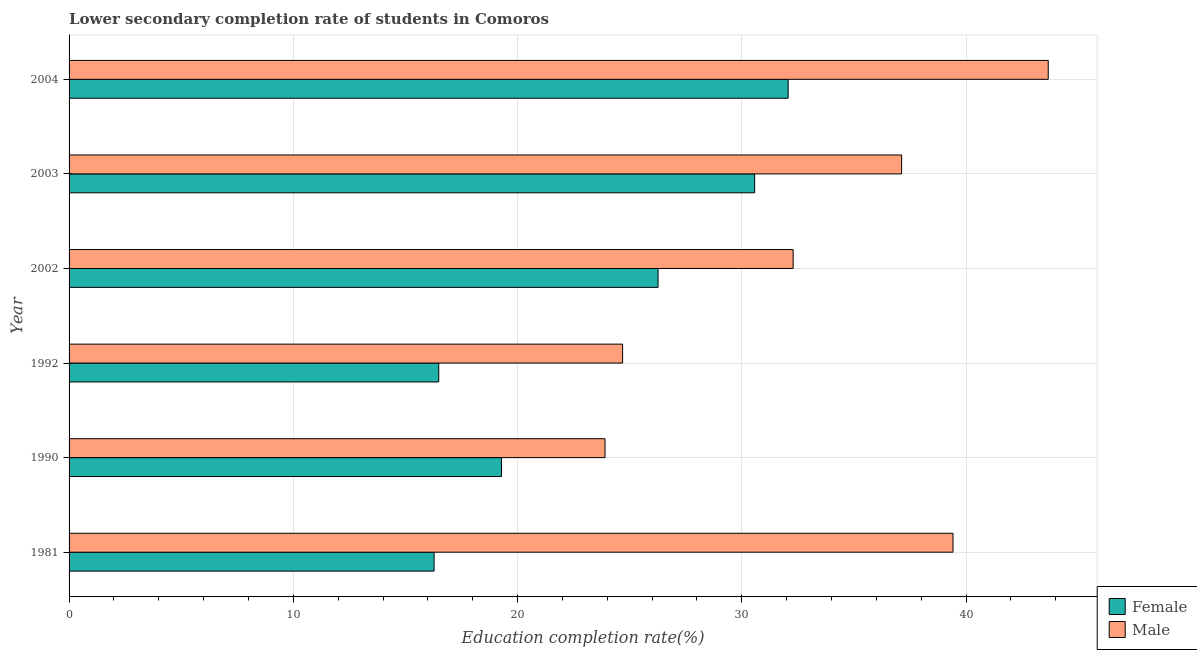How many different coloured bars are there?
Your answer should be very brief. 2. Are the number of bars per tick equal to the number of legend labels?
Provide a short and direct response. Yes. How many bars are there on the 6th tick from the top?
Offer a very short reply. 2. What is the education completion rate of female students in 1992?
Offer a very short reply. 16.49. Across all years, what is the maximum education completion rate of female students?
Offer a very short reply. 32.07. Across all years, what is the minimum education completion rate of male students?
Provide a succinct answer. 23.9. What is the total education completion rate of female students in the graph?
Provide a succinct answer. 140.95. What is the difference between the education completion rate of female students in 1990 and that in 2003?
Give a very brief answer. -11.29. What is the difference between the education completion rate of female students in 2004 and the education completion rate of male students in 1992?
Give a very brief answer. 7.38. What is the average education completion rate of male students per year?
Make the answer very short. 33.51. In the year 2002, what is the difference between the education completion rate of female students and education completion rate of male students?
Your answer should be very brief. -6.02. In how many years, is the education completion rate of male students greater than 32 %?
Keep it short and to the point. 4. What is the ratio of the education completion rate of female students in 2003 to that in 2004?
Make the answer very short. 0.95. Is the education completion rate of male students in 1981 less than that in 1992?
Your answer should be very brief. No. What is the difference between the highest and the second highest education completion rate of male students?
Provide a succinct answer. 4.25. What is the difference between the highest and the lowest education completion rate of female students?
Provide a succinct answer. 15.79. In how many years, is the education completion rate of male students greater than the average education completion rate of male students taken over all years?
Make the answer very short. 3. Is the sum of the education completion rate of female students in 1992 and 2002 greater than the maximum education completion rate of male students across all years?
Give a very brief answer. No. What does the 1st bar from the top in 1981 represents?
Provide a short and direct response. Male. Are all the bars in the graph horizontal?
Offer a terse response. Yes. How many years are there in the graph?
Provide a short and direct response. 6. What is the difference between two consecutive major ticks on the X-axis?
Give a very brief answer. 10. Are the values on the major ticks of X-axis written in scientific E-notation?
Provide a succinct answer. No. Where does the legend appear in the graph?
Your response must be concise. Bottom right. What is the title of the graph?
Ensure brevity in your answer.  Lower secondary completion rate of students in Comoros. What is the label or title of the X-axis?
Keep it short and to the point. Education completion rate(%). What is the Education completion rate(%) of Female in 1981?
Your answer should be compact. 16.28. What is the Education completion rate(%) in Male in 1981?
Your answer should be very brief. 39.42. What is the Education completion rate(%) of Female in 1990?
Your answer should be very brief. 19.28. What is the Education completion rate(%) in Male in 1990?
Provide a succinct answer. 23.9. What is the Education completion rate(%) of Female in 1992?
Keep it short and to the point. 16.49. What is the Education completion rate(%) of Male in 1992?
Make the answer very short. 24.68. What is the Education completion rate(%) of Female in 2002?
Make the answer very short. 26.27. What is the Education completion rate(%) of Male in 2002?
Your answer should be compact. 32.29. What is the Education completion rate(%) in Female in 2003?
Provide a succinct answer. 30.57. What is the Education completion rate(%) of Male in 2003?
Your answer should be very brief. 37.13. What is the Education completion rate(%) of Female in 2004?
Give a very brief answer. 32.07. What is the Education completion rate(%) of Male in 2004?
Give a very brief answer. 43.67. Across all years, what is the maximum Education completion rate(%) in Female?
Provide a succinct answer. 32.07. Across all years, what is the maximum Education completion rate(%) in Male?
Your response must be concise. 43.67. Across all years, what is the minimum Education completion rate(%) of Female?
Offer a very short reply. 16.28. Across all years, what is the minimum Education completion rate(%) in Male?
Provide a succinct answer. 23.9. What is the total Education completion rate(%) in Female in the graph?
Provide a short and direct response. 140.95. What is the total Education completion rate(%) in Male in the graph?
Offer a terse response. 201.09. What is the difference between the Education completion rate(%) in Female in 1981 and that in 1990?
Your answer should be compact. -3.01. What is the difference between the Education completion rate(%) in Male in 1981 and that in 1990?
Offer a terse response. 15.52. What is the difference between the Education completion rate(%) in Female in 1981 and that in 1992?
Give a very brief answer. -0.21. What is the difference between the Education completion rate(%) of Male in 1981 and that in 1992?
Offer a very short reply. 14.74. What is the difference between the Education completion rate(%) of Female in 1981 and that in 2002?
Your answer should be compact. -9.99. What is the difference between the Education completion rate(%) in Male in 1981 and that in 2002?
Provide a short and direct response. 7.13. What is the difference between the Education completion rate(%) of Female in 1981 and that in 2003?
Your answer should be very brief. -14.29. What is the difference between the Education completion rate(%) in Male in 1981 and that in 2003?
Give a very brief answer. 2.29. What is the difference between the Education completion rate(%) in Female in 1981 and that in 2004?
Make the answer very short. -15.79. What is the difference between the Education completion rate(%) of Male in 1981 and that in 2004?
Provide a succinct answer. -4.25. What is the difference between the Education completion rate(%) of Female in 1990 and that in 1992?
Keep it short and to the point. 2.8. What is the difference between the Education completion rate(%) of Male in 1990 and that in 1992?
Provide a succinct answer. -0.78. What is the difference between the Education completion rate(%) in Female in 1990 and that in 2002?
Your answer should be very brief. -6.98. What is the difference between the Education completion rate(%) of Male in 1990 and that in 2002?
Offer a very short reply. -8.39. What is the difference between the Education completion rate(%) of Female in 1990 and that in 2003?
Offer a very short reply. -11.29. What is the difference between the Education completion rate(%) in Male in 1990 and that in 2003?
Provide a succinct answer. -13.23. What is the difference between the Education completion rate(%) in Female in 1990 and that in 2004?
Make the answer very short. -12.78. What is the difference between the Education completion rate(%) of Male in 1990 and that in 2004?
Your answer should be very brief. -19.77. What is the difference between the Education completion rate(%) of Female in 1992 and that in 2002?
Your response must be concise. -9.78. What is the difference between the Education completion rate(%) in Male in 1992 and that in 2002?
Keep it short and to the point. -7.61. What is the difference between the Education completion rate(%) in Female in 1992 and that in 2003?
Your answer should be very brief. -14.09. What is the difference between the Education completion rate(%) of Male in 1992 and that in 2003?
Your response must be concise. -12.44. What is the difference between the Education completion rate(%) of Female in 1992 and that in 2004?
Your answer should be very brief. -15.58. What is the difference between the Education completion rate(%) of Male in 1992 and that in 2004?
Offer a terse response. -18.98. What is the difference between the Education completion rate(%) of Female in 2002 and that in 2003?
Your response must be concise. -4.31. What is the difference between the Education completion rate(%) of Male in 2002 and that in 2003?
Keep it short and to the point. -4.84. What is the difference between the Education completion rate(%) in Female in 2002 and that in 2004?
Your answer should be very brief. -5.8. What is the difference between the Education completion rate(%) of Male in 2002 and that in 2004?
Make the answer very short. -11.38. What is the difference between the Education completion rate(%) in Female in 2003 and that in 2004?
Your answer should be compact. -1.49. What is the difference between the Education completion rate(%) of Male in 2003 and that in 2004?
Ensure brevity in your answer.  -6.54. What is the difference between the Education completion rate(%) in Female in 1981 and the Education completion rate(%) in Male in 1990?
Give a very brief answer. -7.62. What is the difference between the Education completion rate(%) of Female in 1981 and the Education completion rate(%) of Male in 1992?
Provide a short and direct response. -8.41. What is the difference between the Education completion rate(%) of Female in 1981 and the Education completion rate(%) of Male in 2002?
Offer a terse response. -16.01. What is the difference between the Education completion rate(%) of Female in 1981 and the Education completion rate(%) of Male in 2003?
Keep it short and to the point. -20.85. What is the difference between the Education completion rate(%) in Female in 1981 and the Education completion rate(%) in Male in 2004?
Offer a very short reply. -27.39. What is the difference between the Education completion rate(%) of Female in 1990 and the Education completion rate(%) of Male in 1992?
Offer a terse response. -5.4. What is the difference between the Education completion rate(%) of Female in 1990 and the Education completion rate(%) of Male in 2002?
Your response must be concise. -13.01. What is the difference between the Education completion rate(%) of Female in 1990 and the Education completion rate(%) of Male in 2003?
Ensure brevity in your answer.  -17.84. What is the difference between the Education completion rate(%) of Female in 1990 and the Education completion rate(%) of Male in 2004?
Your response must be concise. -24.38. What is the difference between the Education completion rate(%) in Female in 1992 and the Education completion rate(%) in Male in 2002?
Give a very brief answer. -15.8. What is the difference between the Education completion rate(%) of Female in 1992 and the Education completion rate(%) of Male in 2003?
Provide a succinct answer. -20.64. What is the difference between the Education completion rate(%) in Female in 1992 and the Education completion rate(%) in Male in 2004?
Offer a very short reply. -27.18. What is the difference between the Education completion rate(%) of Female in 2002 and the Education completion rate(%) of Male in 2003?
Provide a short and direct response. -10.86. What is the difference between the Education completion rate(%) in Female in 2002 and the Education completion rate(%) in Male in 2004?
Provide a short and direct response. -17.4. What is the difference between the Education completion rate(%) of Female in 2003 and the Education completion rate(%) of Male in 2004?
Provide a succinct answer. -13.09. What is the average Education completion rate(%) of Female per year?
Your answer should be very brief. 23.49. What is the average Education completion rate(%) of Male per year?
Provide a short and direct response. 33.51. In the year 1981, what is the difference between the Education completion rate(%) of Female and Education completion rate(%) of Male?
Offer a terse response. -23.14. In the year 1990, what is the difference between the Education completion rate(%) of Female and Education completion rate(%) of Male?
Your answer should be compact. -4.62. In the year 1992, what is the difference between the Education completion rate(%) of Female and Education completion rate(%) of Male?
Your answer should be very brief. -8.2. In the year 2002, what is the difference between the Education completion rate(%) of Female and Education completion rate(%) of Male?
Offer a very short reply. -6.02. In the year 2003, what is the difference between the Education completion rate(%) of Female and Education completion rate(%) of Male?
Provide a short and direct response. -6.55. In the year 2004, what is the difference between the Education completion rate(%) in Female and Education completion rate(%) in Male?
Your answer should be compact. -11.6. What is the ratio of the Education completion rate(%) of Female in 1981 to that in 1990?
Give a very brief answer. 0.84. What is the ratio of the Education completion rate(%) of Male in 1981 to that in 1990?
Ensure brevity in your answer.  1.65. What is the ratio of the Education completion rate(%) of Female in 1981 to that in 1992?
Provide a succinct answer. 0.99. What is the ratio of the Education completion rate(%) of Male in 1981 to that in 1992?
Provide a succinct answer. 1.6. What is the ratio of the Education completion rate(%) in Female in 1981 to that in 2002?
Offer a very short reply. 0.62. What is the ratio of the Education completion rate(%) of Male in 1981 to that in 2002?
Offer a terse response. 1.22. What is the ratio of the Education completion rate(%) in Female in 1981 to that in 2003?
Offer a terse response. 0.53. What is the ratio of the Education completion rate(%) of Male in 1981 to that in 2003?
Keep it short and to the point. 1.06. What is the ratio of the Education completion rate(%) of Female in 1981 to that in 2004?
Your answer should be compact. 0.51. What is the ratio of the Education completion rate(%) of Male in 1981 to that in 2004?
Your answer should be very brief. 0.9. What is the ratio of the Education completion rate(%) of Female in 1990 to that in 1992?
Offer a terse response. 1.17. What is the ratio of the Education completion rate(%) in Male in 1990 to that in 1992?
Offer a terse response. 0.97. What is the ratio of the Education completion rate(%) of Female in 1990 to that in 2002?
Your answer should be compact. 0.73. What is the ratio of the Education completion rate(%) in Male in 1990 to that in 2002?
Ensure brevity in your answer.  0.74. What is the ratio of the Education completion rate(%) in Female in 1990 to that in 2003?
Your response must be concise. 0.63. What is the ratio of the Education completion rate(%) of Male in 1990 to that in 2003?
Your response must be concise. 0.64. What is the ratio of the Education completion rate(%) in Female in 1990 to that in 2004?
Your answer should be compact. 0.6. What is the ratio of the Education completion rate(%) of Male in 1990 to that in 2004?
Your answer should be compact. 0.55. What is the ratio of the Education completion rate(%) of Female in 1992 to that in 2002?
Keep it short and to the point. 0.63. What is the ratio of the Education completion rate(%) of Male in 1992 to that in 2002?
Ensure brevity in your answer.  0.76. What is the ratio of the Education completion rate(%) in Female in 1992 to that in 2003?
Provide a succinct answer. 0.54. What is the ratio of the Education completion rate(%) of Male in 1992 to that in 2003?
Your response must be concise. 0.66. What is the ratio of the Education completion rate(%) in Female in 1992 to that in 2004?
Your answer should be compact. 0.51. What is the ratio of the Education completion rate(%) in Male in 1992 to that in 2004?
Your response must be concise. 0.57. What is the ratio of the Education completion rate(%) in Female in 2002 to that in 2003?
Offer a terse response. 0.86. What is the ratio of the Education completion rate(%) of Male in 2002 to that in 2003?
Provide a short and direct response. 0.87. What is the ratio of the Education completion rate(%) of Female in 2002 to that in 2004?
Your response must be concise. 0.82. What is the ratio of the Education completion rate(%) in Male in 2002 to that in 2004?
Offer a very short reply. 0.74. What is the ratio of the Education completion rate(%) in Female in 2003 to that in 2004?
Make the answer very short. 0.95. What is the ratio of the Education completion rate(%) of Male in 2003 to that in 2004?
Ensure brevity in your answer.  0.85. What is the difference between the highest and the second highest Education completion rate(%) of Female?
Make the answer very short. 1.49. What is the difference between the highest and the second highest Education completion rate(%) in Male?
Your answer should be very brief. 4.25. What is the difference between the highest and the lowest Education completion rate(%) in Female?
Give a very brief answer. 15.79. What is the difference between the highest and the lowest Education completion rate(%) of Male?
Provide a succinct answer. 19.77. 